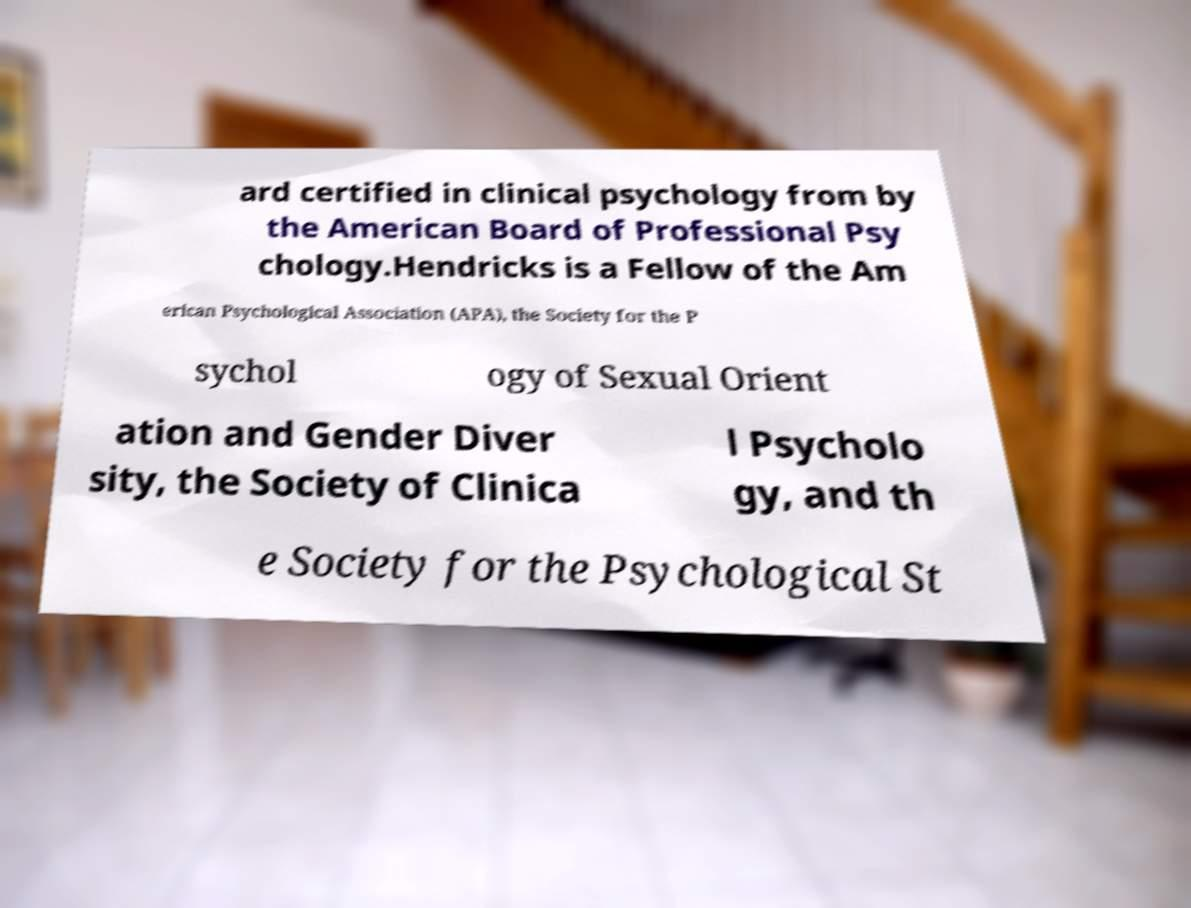Can you read and provide the text displayed in the image?This photo seems to have some interesting text. Can you extract and type it out for me? ard certified in clinical psychology from by the American Board of Professional Psy chology.Hendricks is a Fellow of the Am erican Psychological Association (APA), the Society for the P sychol ogy of Sexual Orient ation and Gender Diver sity, the Society of Clinica l Psycholo gy, and th e Society for the Psychological St 